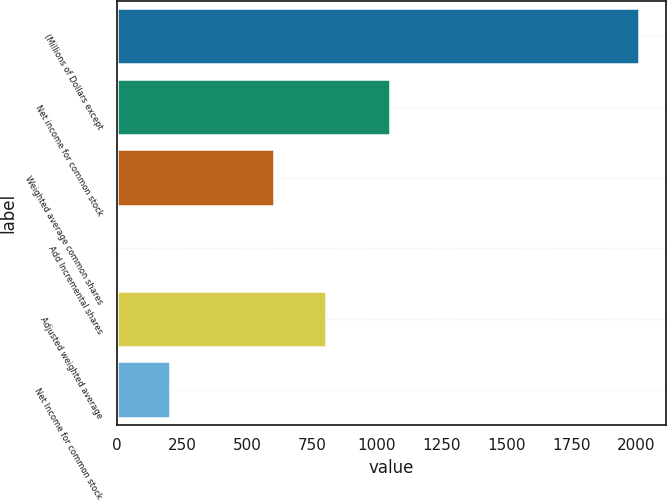Convert chart to OTSL. <chart><loc_0><loc_0><loc_500><loc_500><bar_chart><fcel>(Millions of Dollars except<fcel>Net income for common stock<fcel>Weighted average common shares<fcel>Add Incremental shares<fcel>Adjusted weighted average<fcel>Net Income for common stock<nl><fcel>2011<fcel>1051<fcel>604.56<fcel>1.8<fcel>805.48<fcel>202.72<nl></chart> 